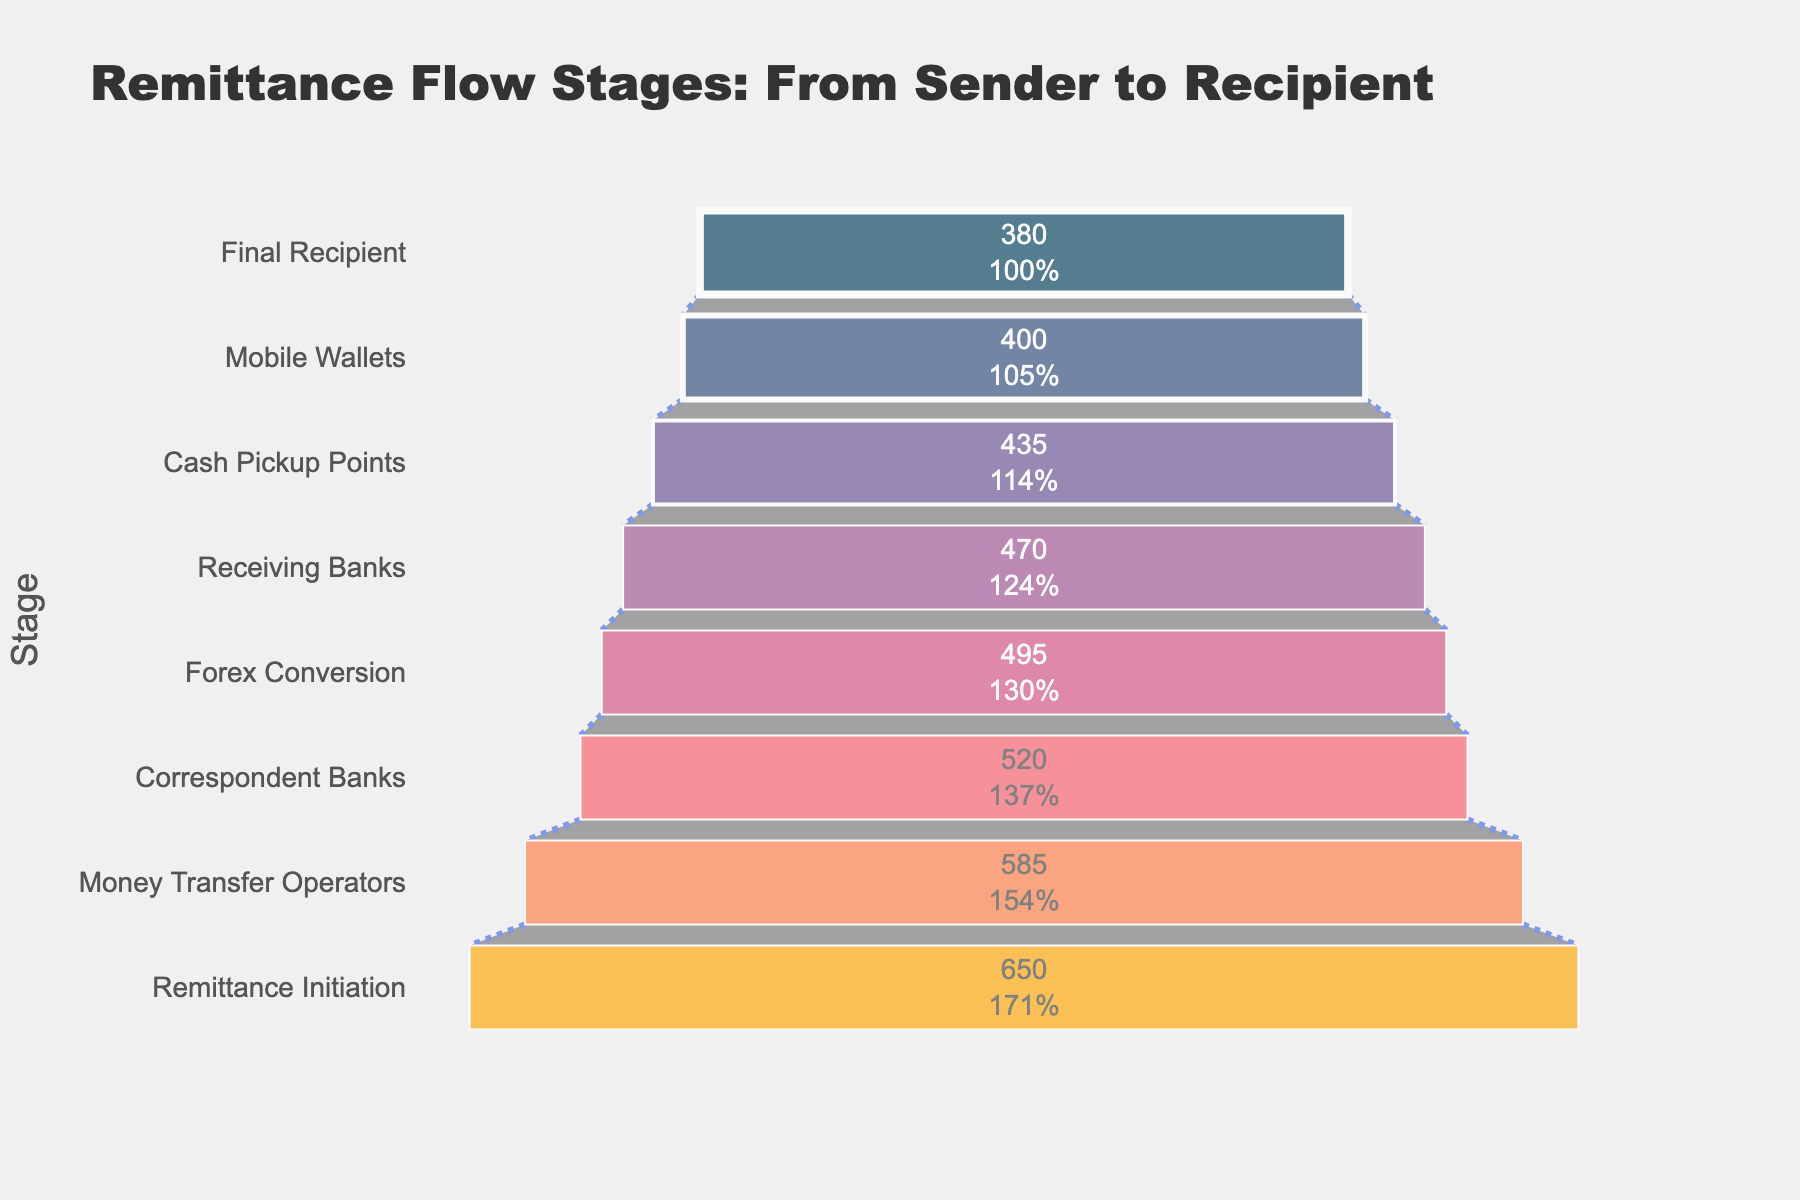What is the title of the chart? The title is located at the top of the chart and provides a summary of what the chart is about. The title reads "Remittance Flow Stages: From Sender to Recipient."
Answer: Remittance Flow Stages: From Sender to Recipient How many stages are shown in the funnel chart? By counting the number of horizontal bars labeled with different stages, we can see there are eight stages in the funnel chart.
Answer: Eight What is the amount at the "Remittance Initiation" stage? The value for the "Remittance Initiation" stage is labeled on the first horizontal bar in the funnel chart. It shows 650 Billion USD.
Answer: 650 Billion USD What is the total amount lost from the "Remittance Initiation" stage to the "Final Recipient" stage? To find the total amount lost, subtract the amount at the "Final Recipient" stage from the amount at the "Remittance Initiation" stage: 650 Billion USD - 380 Billion USD = 270 Billion USD.
Answer: 270 Billion USD What is the average amount retained in each stage after "Remittance Initiation"? First, sum the amounts remaining at each stage after the "Remittance Initiation" stage: 585 + 520 + 495 + 470 + 435 + 400 + 380 = 3,285 Billion USD. Then, divide by the number of stages (7): 3,285 Billion USD / 7 ≈ 469.29 Billion USD.
Answer: 469.29 Billion USD Which stage shows the largest drop in the amount of remittance compared to its previous stage? Compare the differences in amounts between each consecutive pair of stages. The largest drop occurs between "Remittance Initiation" (650 Billion USD) and "Money Transfer Operators" (585 Billion USD), which is 650 - 585 = 65 Billion USD.
Answer: Remittance Initiation to Money Transfer Operators Does the "Cash Pickup Points" stage retain more remittance than the "Mobile Wallets" stage? Compare the amounts retained at "Cash Pickup Points" (435 Billion USD) and "Mobile Wallets" (400 Billion USD). Since 435 Billion USD is greater than 400 Billion USD, the "Cash Pickup Points" stage retains more remittance.
Answer: Yes What percentage of remittance is retained at the "Receiving Banks" stage relative to the initial amount? Divide the amount at the "Receiving Banks" stage (470 Billion USD) by the initial amount (650 Billion USD) and multiply by 100 to get the percentage: (470 / 650) * 100 ≈ 72.31%.
Answer: 72.31% Which stage has the smallest percentage of the initial remittance amount? By reviewing the percentages (text info inside the bars), "Final Recipient" retains 58.46% of the initial amount, lower than any other stages' percentages.
Answer: Final Recipient What is the purpose of the connector lines in the funnel chart? The connector lines with dotted patterns between the stages visually denote the transition and flow of remittance from one stage to the next, emphasizing changes in amounts as they connect each step in the process.
Answer: To show transitions between stages 